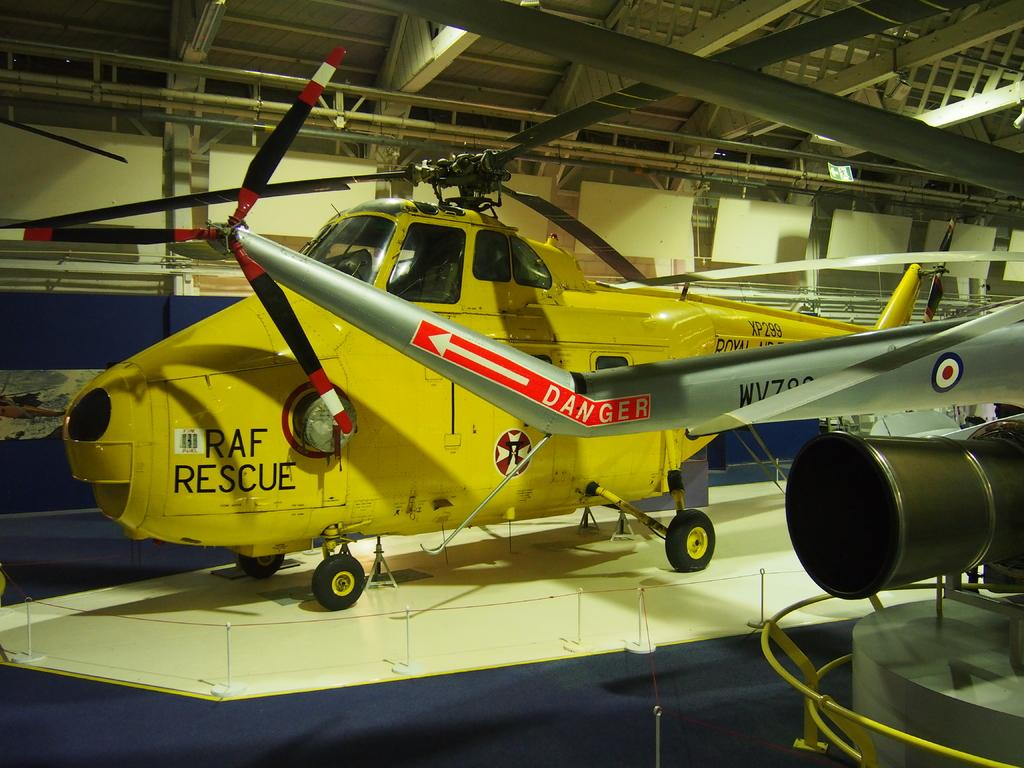What objects are on the floor in the image? There are planes on the floor in the image. What type of roof is visible at the top of the image? There is an iron roof visible at the top of the image. How does the quince affect the waves in the image? There is no quince or waves present in the image. What type of tub is visible in the image? There is no tub present in the image. 